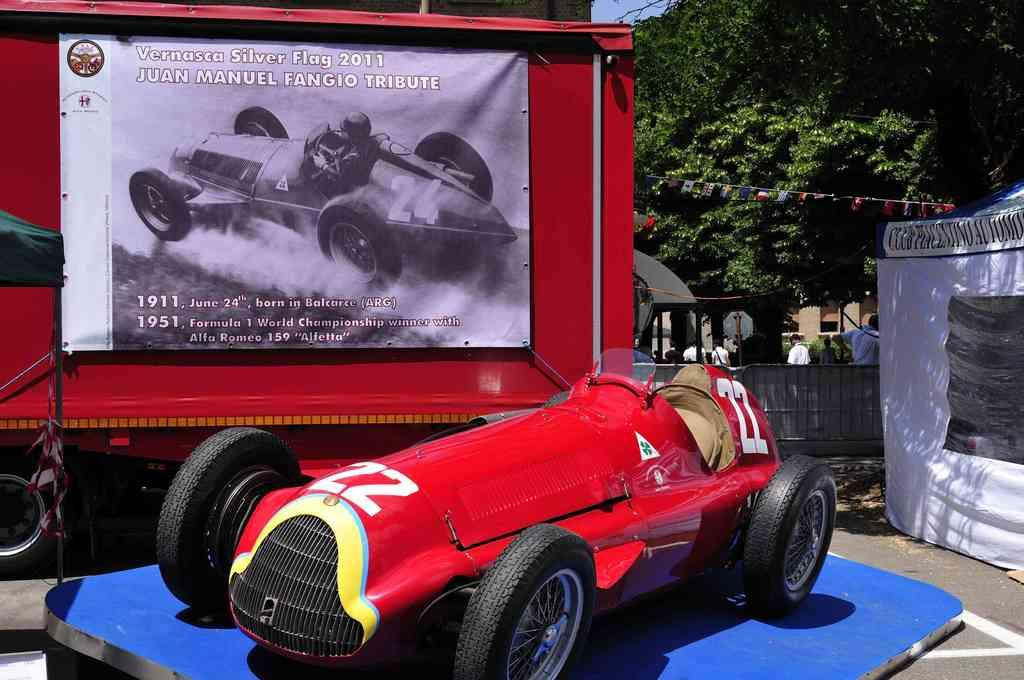What can be seen in the sky in the image? The sky is visible in the image. What type of natural vegetation is present in the image? There are trees in the image. What are the persons in the image doing? The persons are standing on the road in the image. What type of transportation is present in the image? Motor vehicles are present in the image. What type of commercial signage is visible in the image? Advertisement boards are visible in the image. What type of temporary shelter is present in the image? Tents are present in the image. How much sugar is being used by the coach in the image? There is no coach or sugar present in the image. What emotion is being displayed by the disgust in the image? There is no disgust present in the image. 